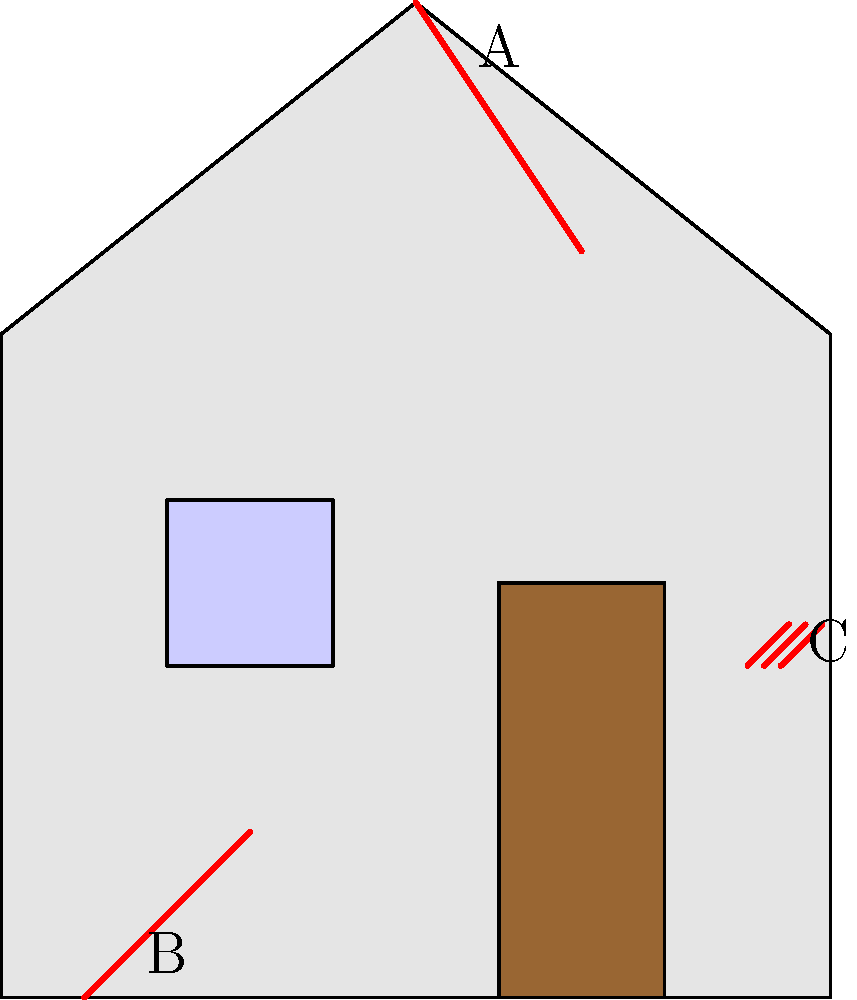In the image of a house exterior, three potential structural issues are highlighted in red and labeled A, B, and C. Which of these issues is likely to be the most serious and require immediate attention? To determine which issue is likely the most serious, let's analyze each one:

1. Issue A: This appears to be a crack in the roof. While roof issues can lead to water damage and should be addressed, they are often not immediately structurally threatening.

2. Issue B: This is a crack in the foundation. Foundation issues are typically the most serious structural problems a house can face. They can lead to:
   - Uneven settling of the house
   - Damage to other structural elements
   - Water intrusion
   - Increased risk of collapse in severe cases

3. Issue C: This seems to be an issue with the siding. While siding problems can lead to water damage and should be fixed, they are generally cosmetic and not structurally critical.

Among these, the foundation crack (B) is the most serious. Foundation issues can compromise the entire structural integrity of the house and often require expensive, extensive repairs. They can also worsen quickly if not addressed, potentially leading to more severe structural damage.

Roof and siding issues, while important, generally don't pose an immediate threat to the house's structural stability and can often be addressed with less urgency than foundation problems.
Answer: B (foundation crack) 